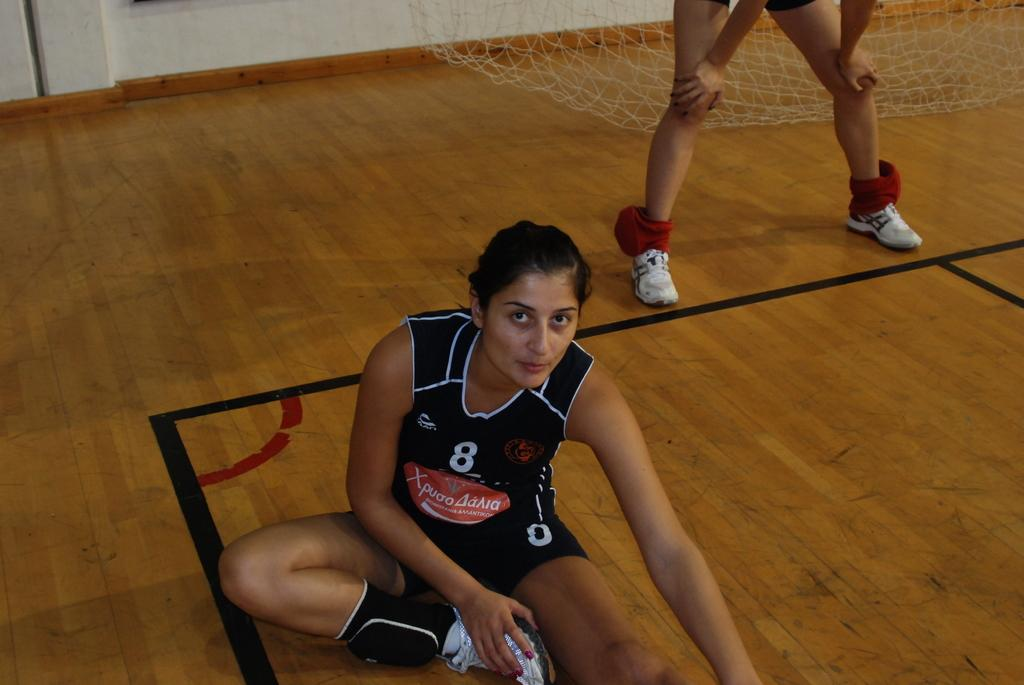What is the woman in the image doing? The woman is sitting on the floor in the image. Can you describe the person in the background of the image? There is a person standing in the background of the image. What object can be seen in the image that resembles a net? There is a white net in the image. What type of lettuce is on the star in the image? There is no lettuce or star present in the image. 